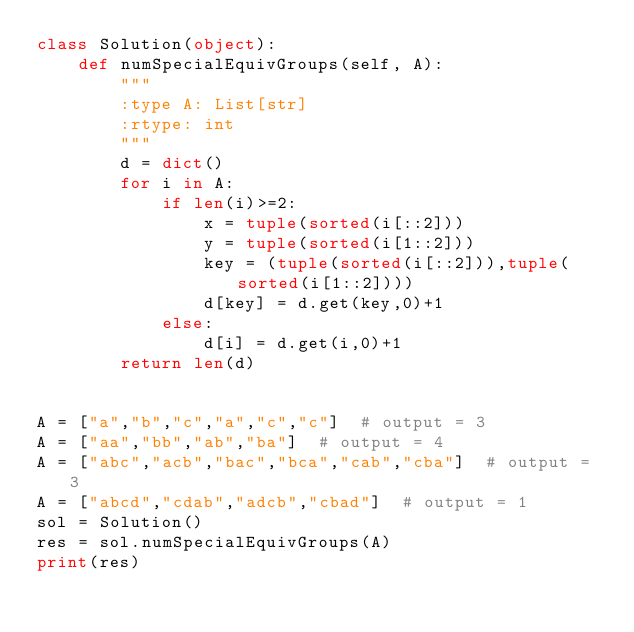Convert code to text. <code><loc_0><loc_0><loc_500><loc_500><_Python_>class Solution(object):
    def numSpecialEquivGroups(self, A):
        """
        :type A: List[str]
        :rtype: int
        """
        d = dict()
        for i in A:
            if len(i)>=2:
                x = tuple(sorted(i[::2]))
                y = tuple(sorted(i[1::2]))
                key = (tuple(sorted(i[::2])),tuple(sorted(i[1::2])))
                d[key] = d.get(key,0)+1
            else:
                d[i] = d.get(i,0)+1
        return len(d)


A = ["a","b","c","a","c","c"]  # output = 3
A = ["aa","bb","ab","ba"]  # output = 4
A = ["abc","acb","bac","bca","cab","cba"]  # output = 3
A = ["abcd","cdab","adcb","cbad"]  # output = 1
sol = Solution()
res = sol.numSpecialEquivGroups(A)
print(res)</code> 